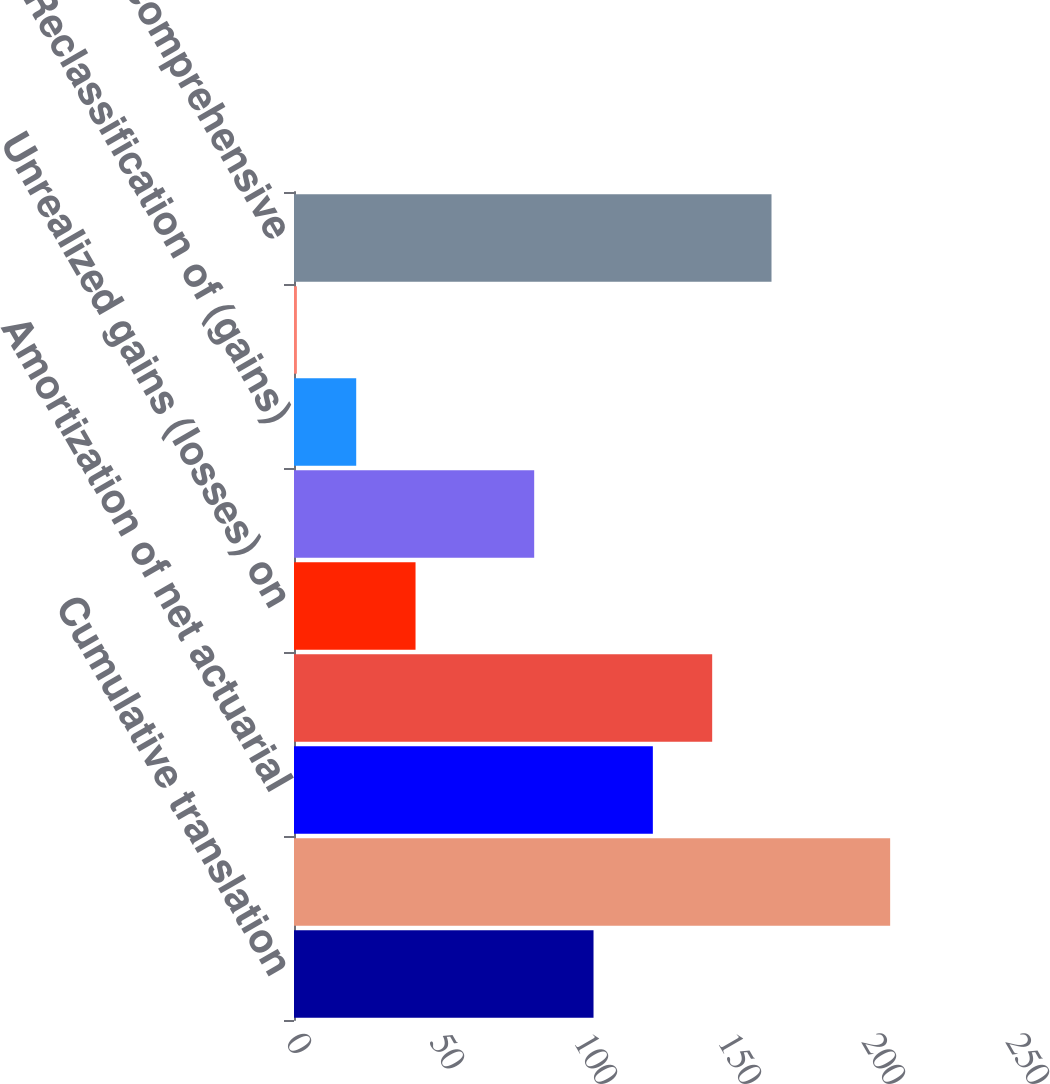<chart> <loc_0><loc_0><loc_500><loc_500><bar_chart><fcel>Cumulative translation<fcel>Net actuarial gain (loss) and<fcel>Amortization of net actuarial<fcel>Retirement Plan and other<fcel>Unrealized gains (losses) on<fcel>Gains (losses) on<fcel>Reclassification of (gains)<fcel>Gains (losses) on cash flow<fcel>Total Other comprehensive<nl><fcel>104<fcel>207<fcel>124.6<fcel>145.2<fcel>42.2<fcel>83.4<fcel>21.6<fcel>1<fcel>165.8<nl></chart> 